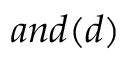Convert formula to latex. <formula><loc_0><loc_0><loc_500><loc_500>a n d ( d )</formula> 